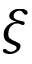<formula> <loc_0><loc_0><loc_500><loc_500>\xi</formula> 